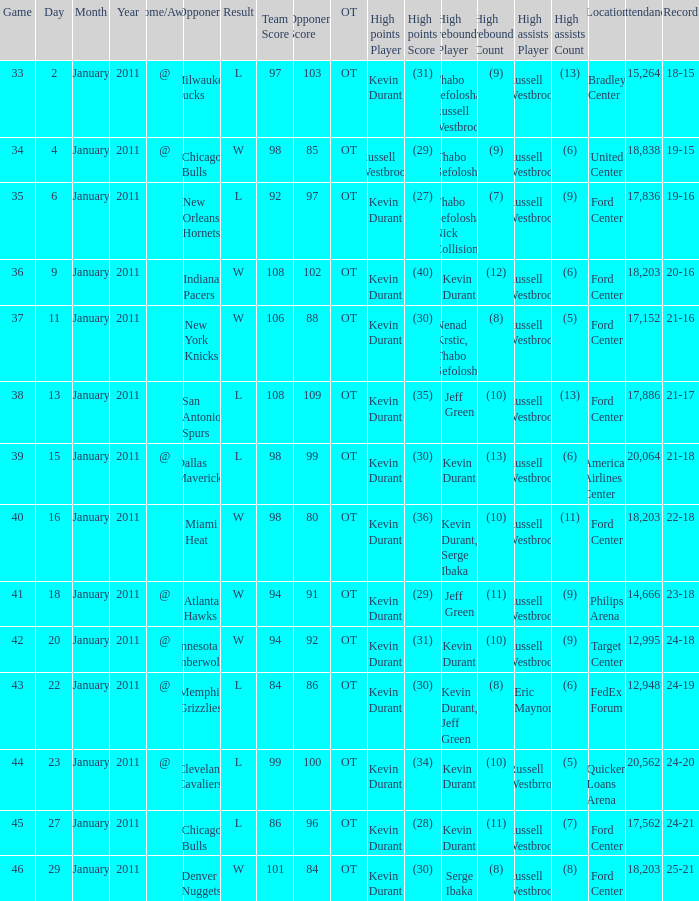Name the least game for january 29 46.0. 